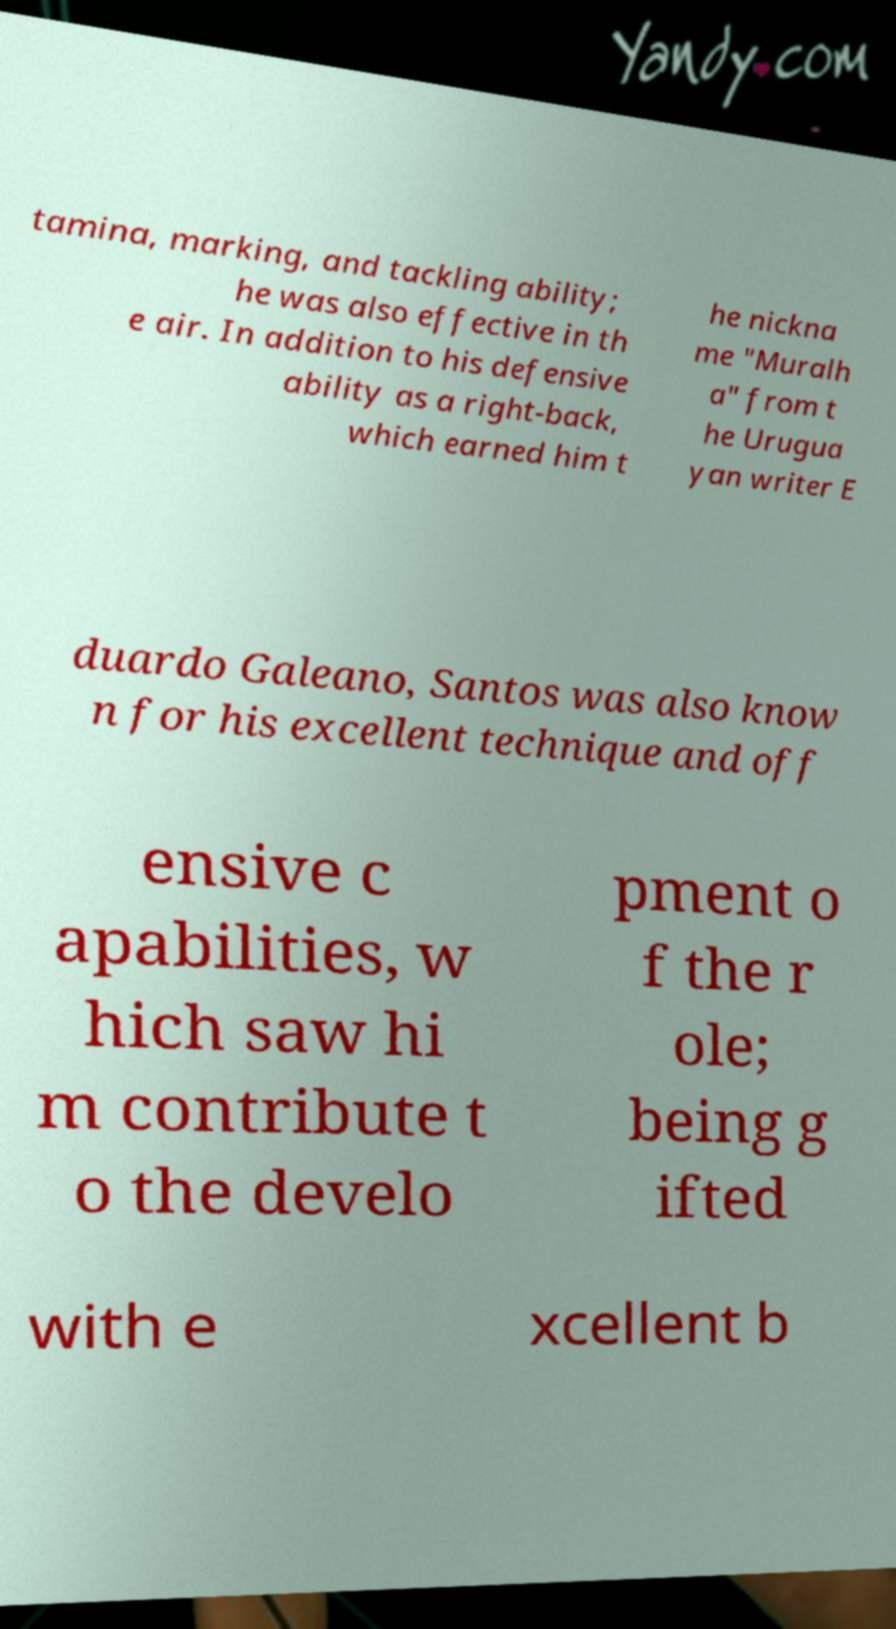What messages or text are displayed in this image? I need them in a readable, typed format. tamina, marking, and tackling ability; he was also effective in th e air. In addition to his defensive ability as a right-back, which earned him t he nickna me "Muralh a" from t he Urugua yan writer E duardo Galeano, Santos was also know n for his excellent technique and off ensive c apabilities, w hich saw hi m contribute t o the develo pment o f the r ole; being g ifted with e xcellent b 